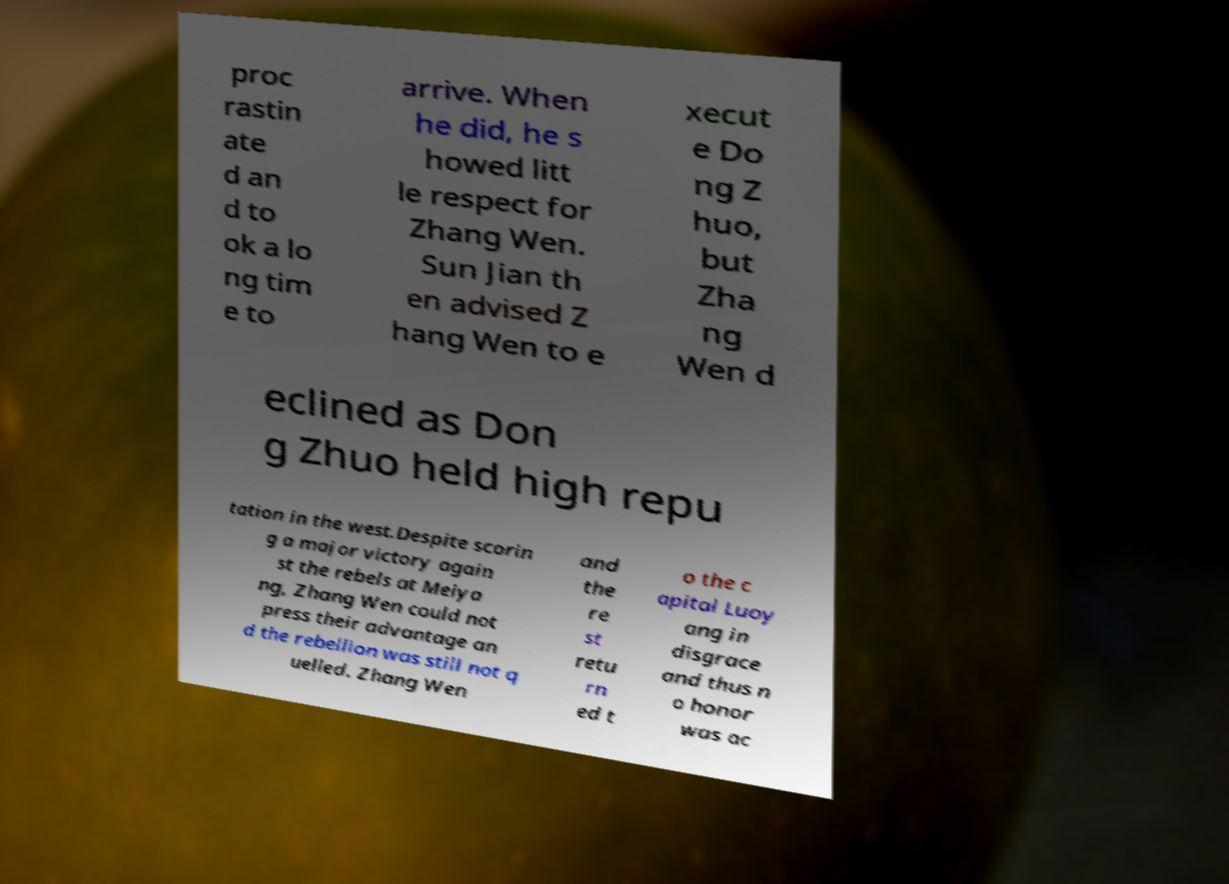For documentation purposes, I need the text within this image transcribed. Could you provide that? proc rastin ate d an d to ok a lo ng tim e to arrive. When he did, he s howed litt le respect for Zhang Wen. Sun Jian th en advised Z hang Wen to e xecut e Do ng Z huo, but Zha ng Wen d eclined as Don g Zhuo held high repu tation in the west.Despite scorin g a major victory again st the rebels at Meiya ng, Zhang Wen could not press their advantage an d the rebellion was still not q uelled. Zhang Wen and the re st retu rn ed t o the c apital Luoy ang in disgrace and thus n o honor was ac 